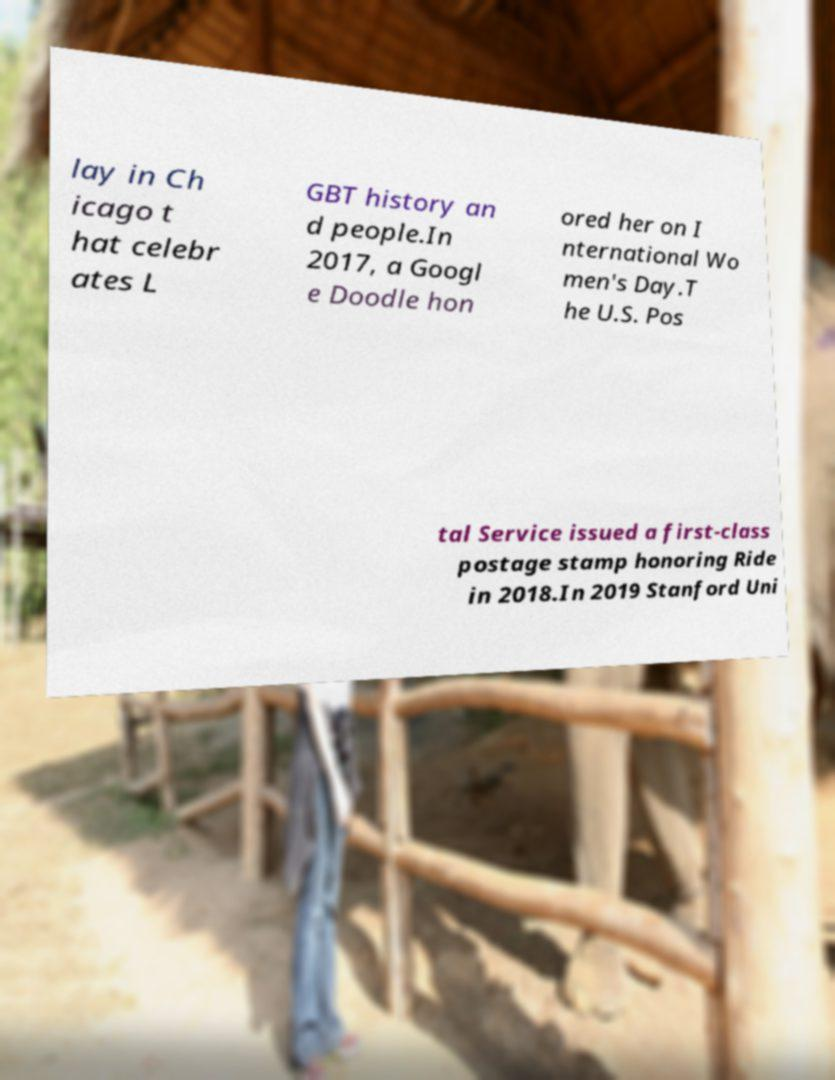Please read and relay the text visible in this image. What does it say? lay in Ch icago t hat celebr ates L GBT history an d people.In 2017, a Googl e Doodle hon ored her on I nternational Wo men's Day.T he U.S. Pos tal Service issued a first-class postage stamp honoring Ride in 2018.In 2019 Stanford Uni 